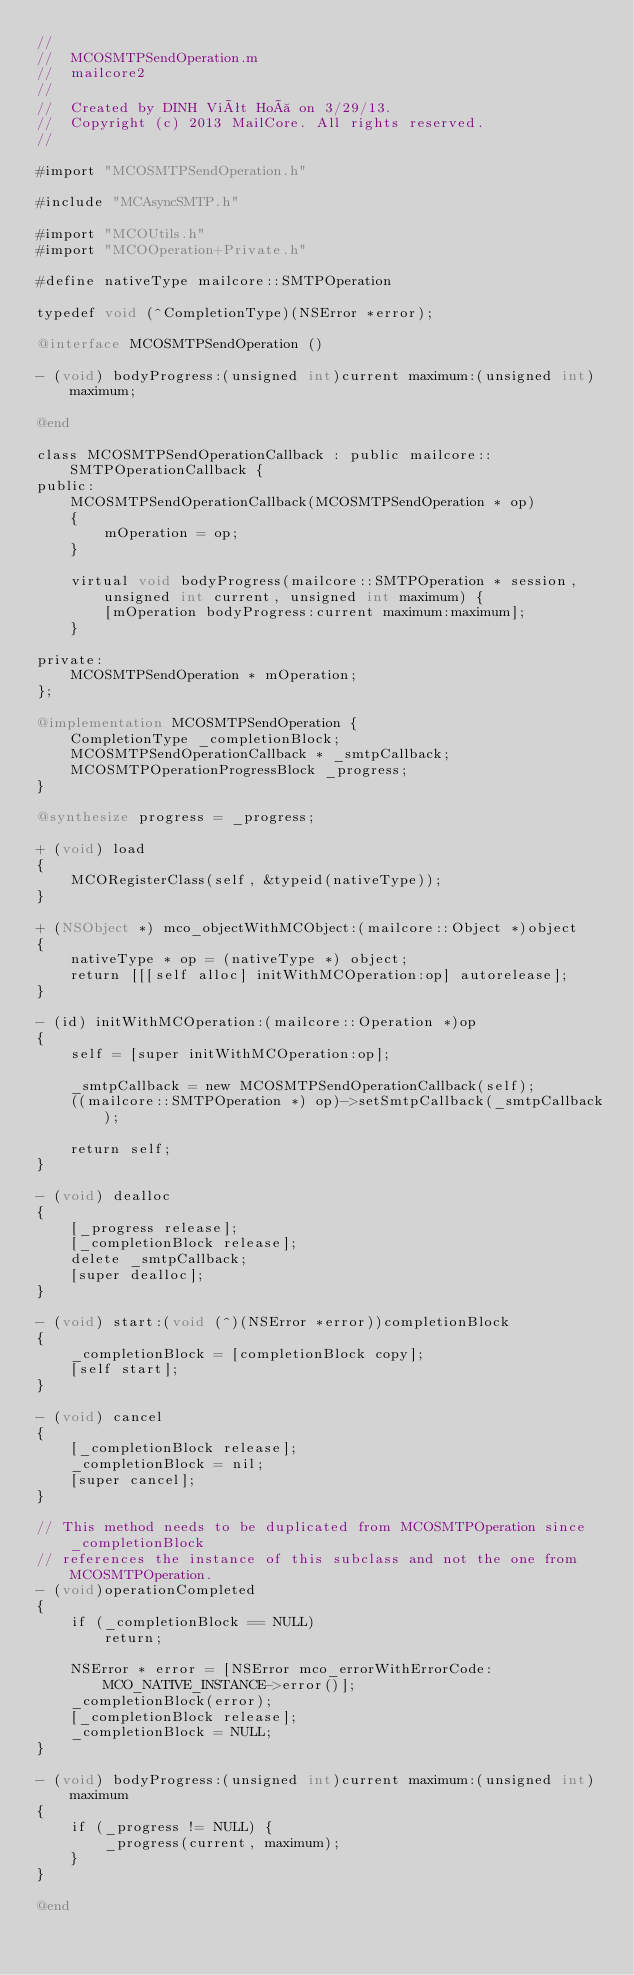<code> <loc_0><loc_0><loc_500><loc_500><_ObjectiveC_>//
//  MCOSMTPSendOperation.m
//  mailcore2
//
//  Created by DINH Viêt Hoà on 3/29/13.
//  Copyright (c) 2013 MailCore. All rights reserved.
//

#import "MCOSMTPSendOperation.h"

#include "MCAsyncSMTP.h"

#import "MCOUtils.h"
#import "MCOOperation+Private.h"

#define nativeType mailcore::SMTPOperation

typedef void (^CompletionType)(NSError *error);

@interface MCOSMTPSendOperation ()

- (void) bodyProgress:(unsigned int)current maximum:(unsigned int)maximum;

@end

class MCOSMTPSendOperationCallback : public mailcore::SMTPOperationCallback {
public:
    MCOSMTPSendOperationCallback(MCOSMTPSendOperation * op)
    {
        mOperation = op;
    }
    
    virtual void bodyProgress(mailcore::SMTPOperation * session, unsigned int current, unsigned int maximum) {
        [mOperation bodyProgress:current maximum:maximum];
    }
    
private:
    MCOSMTPSendOperation * mOperation;
};

@implementation MCOSMTPSendOperation {
    CompletionType _completionBlock;
    MCOSMTPSendOperationCallback * _smtpCallback;
    MCOSMTPOperationProgressBlock _progress;
}

@synthesize progress = _progress;

+ (void) load
{
    MCORegisterClass(self, &typeid(nativeType));
}

+ (NSObject *) mco_objectWithMCObject:(mailcore::Object *)object
{
    nativeType * op = (nativeType *) object;
    return [[[self alloc] initWithMCOperation:op] autorelease];
}

- (id) initWithMCOperation:(mailcore::Operation *)op
{
    self = [super initWithMCOperation:op];
    
    _smtpCallback = new MCOSMTPSendOperationCallback(self);
    ((mailcore::SMTPOperation *) op)->setSmtpCallback(_smtpCallback);
    
    return self;
}

- (void) dealloc
{
    [_progress release];
    [_completionBlock release];
    delete _smtpCallback;
    [super dealloc];
}

- (void) start:(void (^)(NSError *error))completionBlock
{
    _completionBlock = [completionBlock copy];
    [self start];
}

- (void) cancel
{
    [_completionBlock release];
    _completionBlock = nil;
    [super cancel];
}

// This method needs to be duplicated from MCOSMTPOperation since _completionBlock
// references the instance of this subclass and not the one from MCOSMTPOperation.
- (void)operationCompleted
{
    if (_completionBlock == NULL)
        return;
    
    NSError * error = [NSError mco_errorWithErrorCode:MCO_NATIVE_INSTANCE->error()];
    _completionBlock(error);
    [_completionBlock release];
    _completionBlock = NULL;
}

- (void) bodyProgress:(unsigned int)current maximum:(unsigned int)maximum
{
    if (_progress != NULL) {
        _progress(current, maximum);
    }
}

@end
</code> 